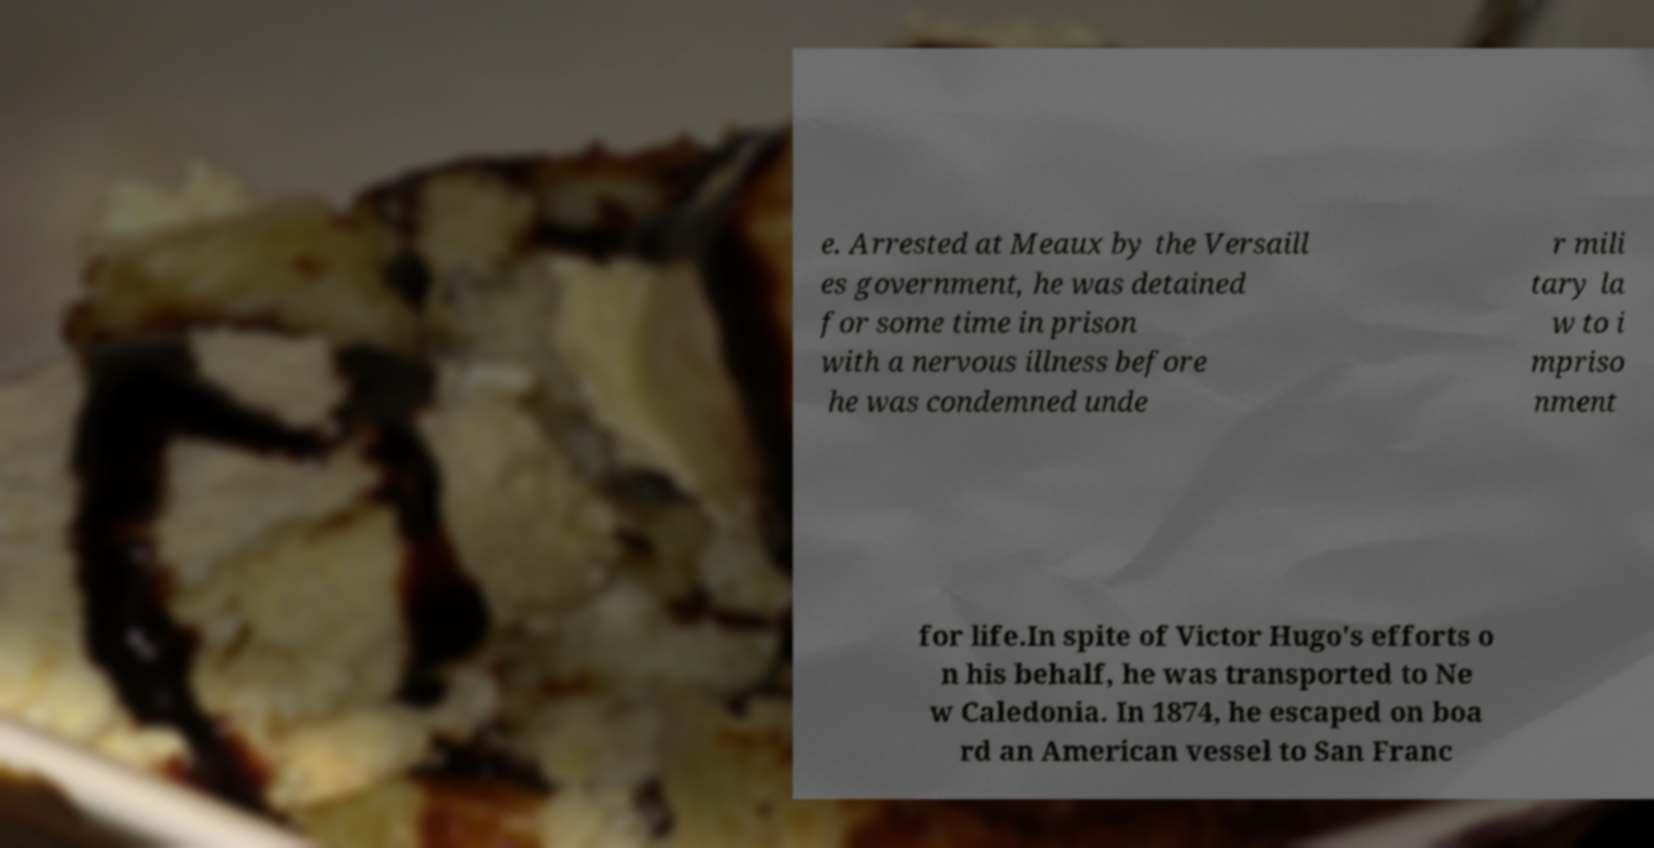What messages or text are displayed in this image? I need them in a readable, typed format. e. Arrested at Meaux by the Versaill es government, he was detained for some time in prison with a nervous illness before he was condemned unde r mili tary la w to i mpriso nment for life.In spite of Victor Hugo's efforts o n his behalf, he was transported to Ne w Caledonia. In 1874, he escaped on boa rd an American vessel to San Franc 